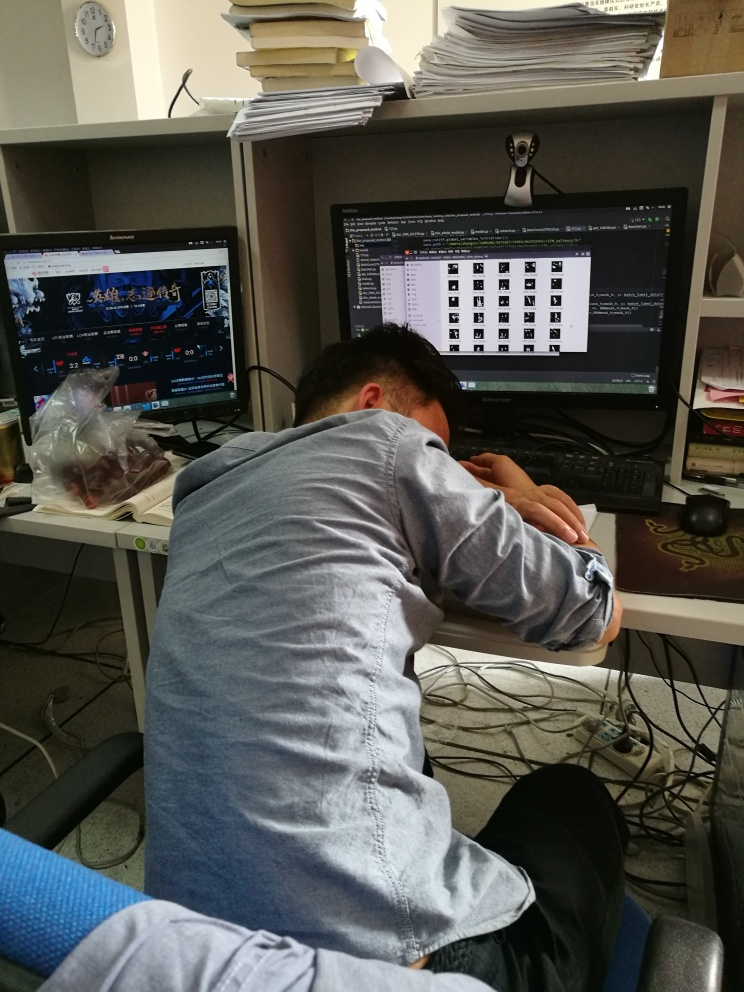What might the person in the photo be feeling or thinking? Based on the image, the individual appears to be overwhelmed or fatigued, indicated by the posture of resting the head on the desk. The scattered papers and active computer screens suggest a busy work environment, potentially leading to feelings of stress or burnout. The person may be contemplating the workload, seeking a moment of rest, or experiencing a sense of defeat in face of the seemingly endless tasks. How could this image represent modern work culture? This image may represent the increasingly blurred lines between work and personal life, as evidenced by the open gaming website during work hours. It underscores the pressures of multitasking and the constant connectivity demanded by modern work culture, which can lead to exhaustion. Additionally, it speaks to the casual nature of some contemporary workspaces, while also highlighting the negative aspects such as improper work-life balance and digital overload. 